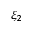<formula> <loc_0><loc_0><loc_500><loc_500>\xi _ { 2 }</formula> 